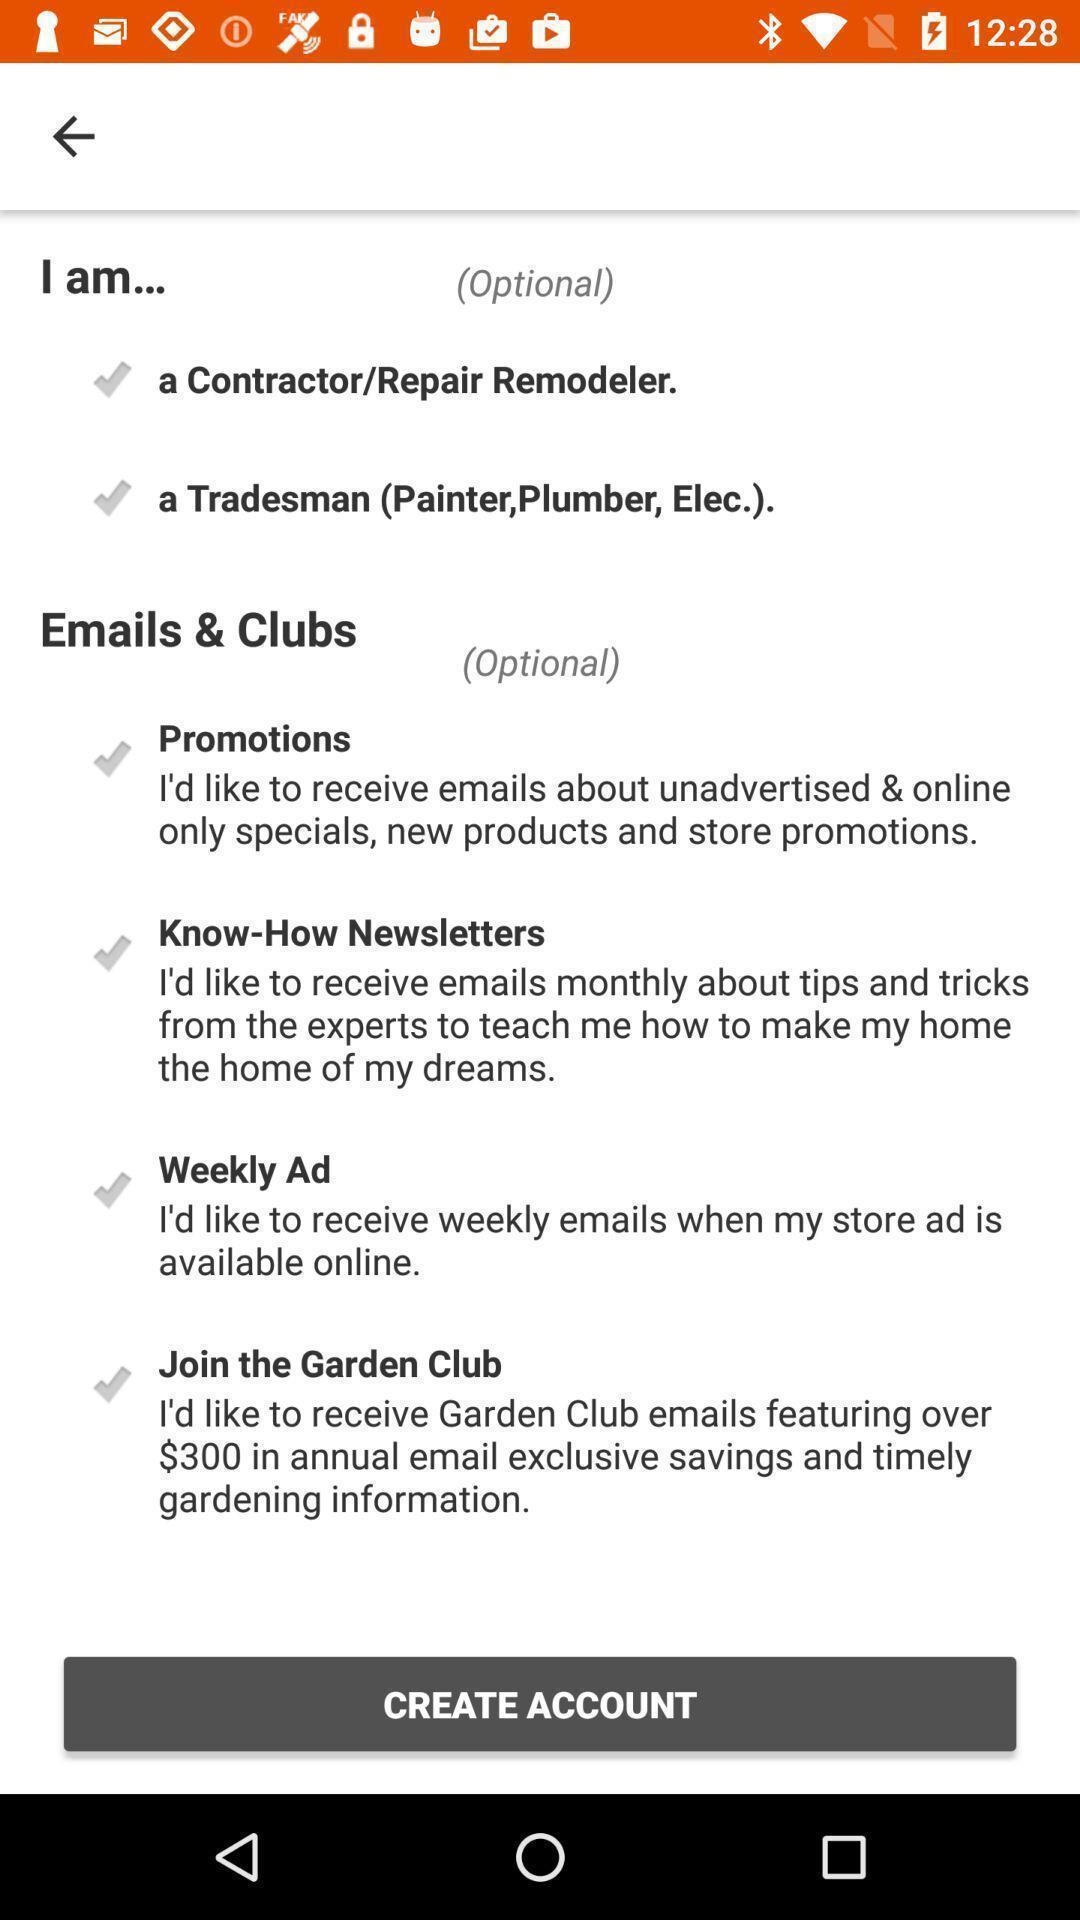Give me a narrative description of this picture. Welcome page for creating account on shopping app. 